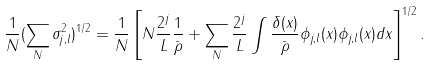Convert formula to latex. <formula><loc_0><loc_0><loc_500><loc_500>\frac { 1 } { N } ( \sum _ { N } \sigma ^ { 2 } _ { j , l } ) ^ { 1 / 2 } = \frac { 1 } { N } \left [ N \frac { 2 ^ { j } } { L } \frac { 1 } { \bar { \rho } } + \sum _ { N } \frac { 2 ^ { j } } { L } \int \frac { \delta ( x ) } { \bar { \rho } } \phi _ { j , l } ( x ) \phi _ { j , l } ( x ) d x \right ] ^ { 1 / 2 } .</formula> 